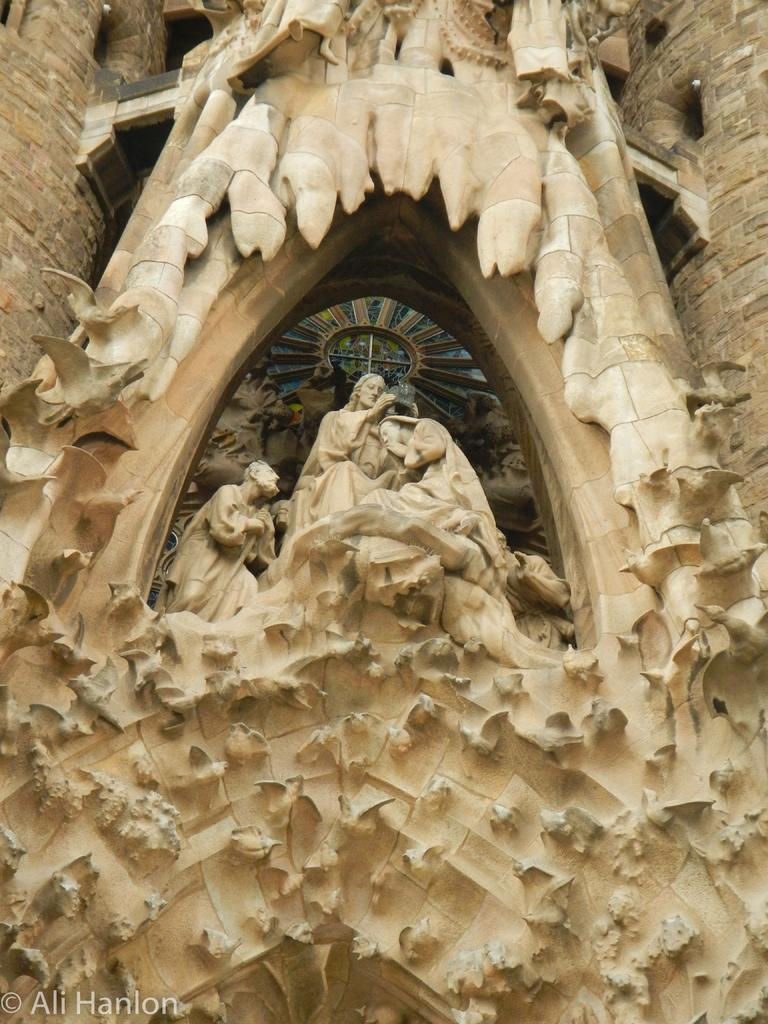What type of sculptures are present in the image? There are wooden sculpture statues in the image. How large are the statues? The statues are huge. What is the surrounding structure of the statues? The statues are in the middle of brick pillars. How many pages are there in the wooden sculpture statue in the image? There are no pages present in the wooden sculpture statue, as it is a sculpture and not a book or document. 